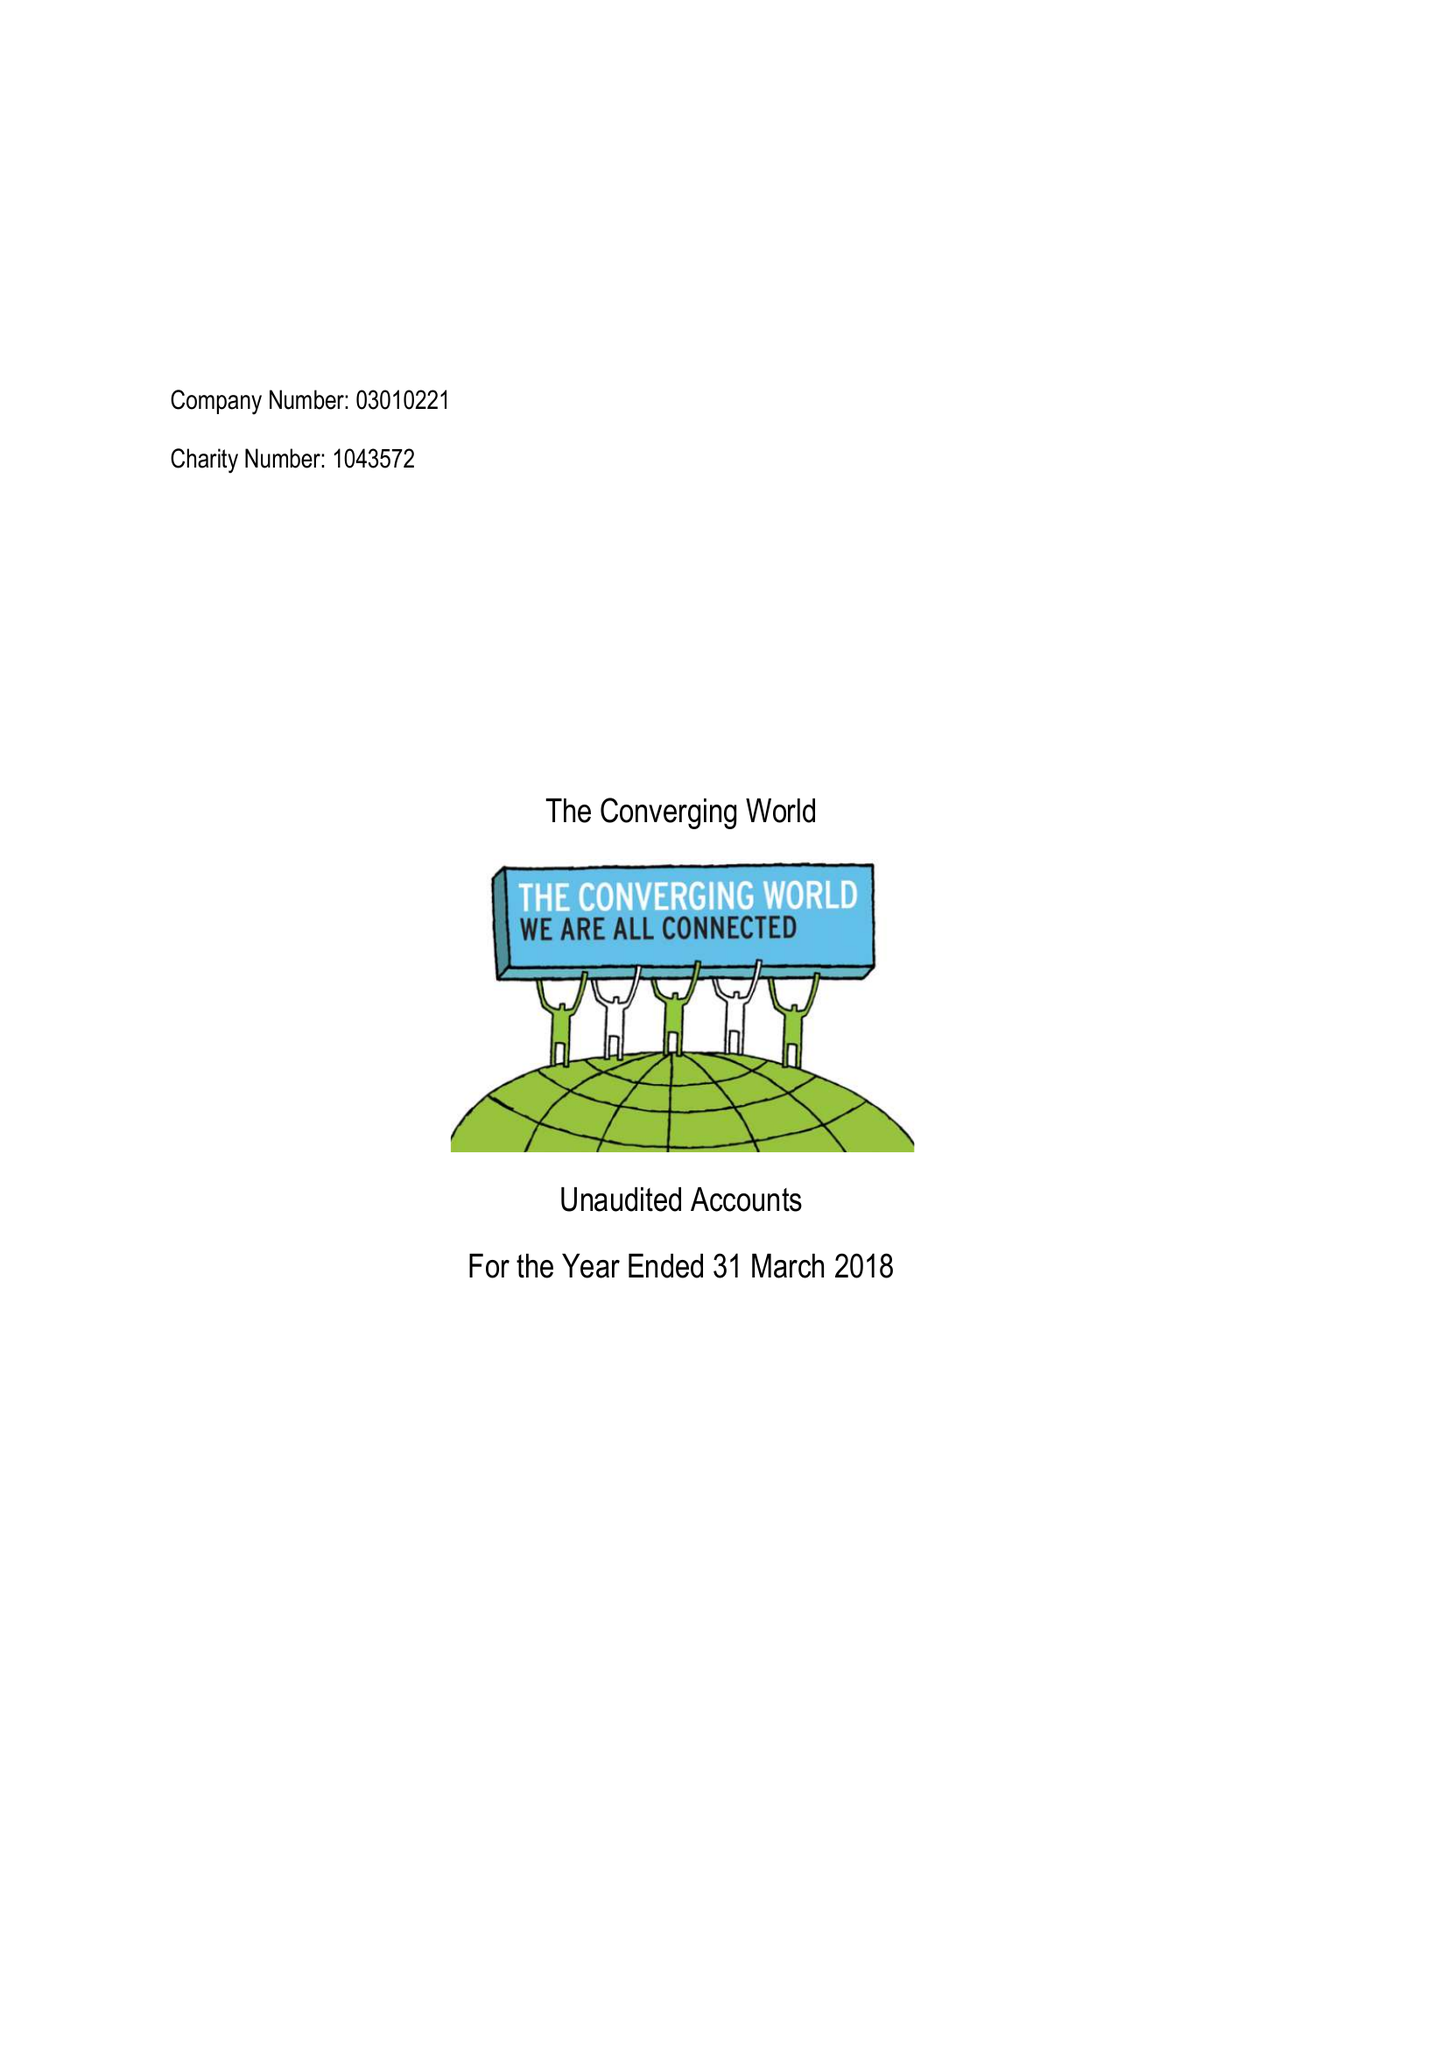What is the value for the address__post_town?
Answer the question using a single word or phrase. BRISTOL 